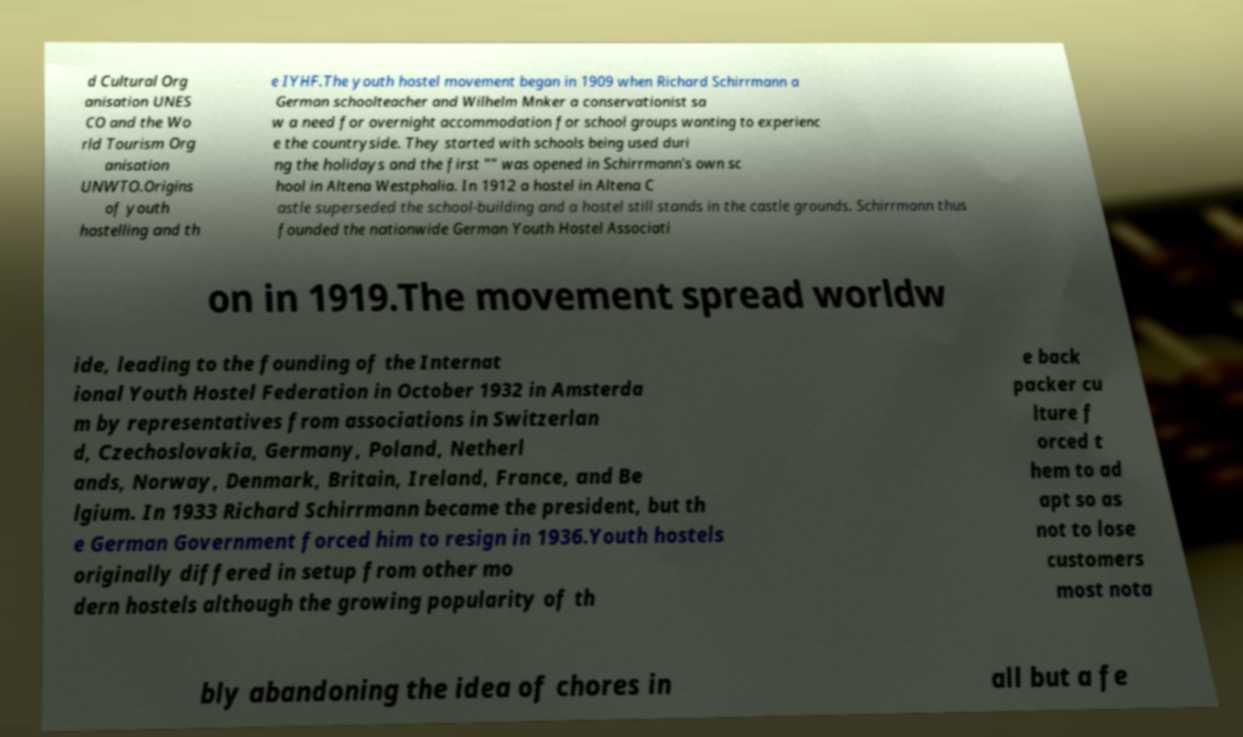Please read and relay the text visible in this image. What does it say? d Cultural Org anisation UNES CO and the Wo rld Tourism Org anisation UNWTO.Origins of youth hostelling and th e IYHF.The youth hostel movement began in 1909 when Richard Schirrmann a German schoolteacher and Wilhelm Mnker a conservationist sa w a need for overnight accommodation for school groups wanting to experienc e the countryside. They started with schools being used duri ng the holidays and the first "" was opened in Schirrmann's own sc hool in Altena Westphalia. In 1912 a hostel in Altena C astle superseded the school-building and a hostel still stands in the castle grounds. Schirrmann thus founded the nationwide German Youth Hostel Associati on in 1919.The movement spread worldw ide, leading to the founding of the Internat ional Youth Hostel Federation in October 1932 in Amsterda m by representatives from associations in Switzerlan d, Czechoslovakia, Germany, Poland, Netherl ands, Norway, Denmark, Britain, Ireland, France, and Be lgium. In 1933 Richard Schirrmann became the president, but th e German Government forced him to resign in 1936.Youth hostels originally differed in setup from other mo dern hostels although the growing popularity of th e back packer cu lture f orced t hem to ad apt so as not to lose customers most nota bly abandoning the idea of chores in all but a fe 